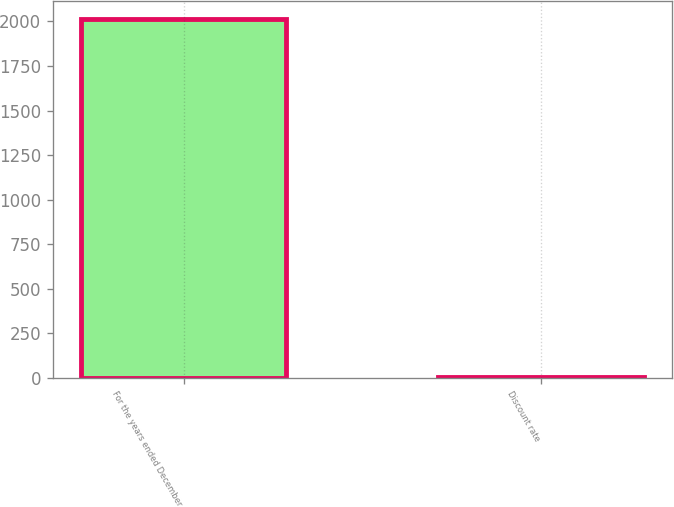Convert chart to OTSL. <chart><loc_0><loc_0><loc_500><loc_500><bar_chart><fcel>For the years ended December<fcel>Discount rate<nl><fcel>2012<fcel>4.5<nl></chart> 